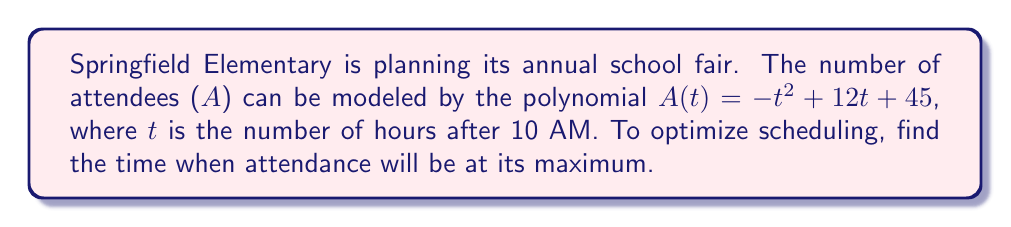Can you answer this question? To find the maximum attendance, we need to find the vertex of the quadratic function $A(t) = -t^2 + 12t + 45$. We can do this by following these steps:

1) The general form of a quadratic function is $f(x) = ax^2 + bx + c$
   In our case, $a = -1$, $b = 12$, and $c = 45$

2) For a quadratic function, the x-coordinate of the vertex is given by $-\frac{b}{2a}$

3) Let's calculate:
   $$t = -\frac{b}{2a} = -\frac{12}{2(-1)} = -\frac{12}{-2} = 6$$

4) This means attendance will be at its maximum 6 hours after 10 AM, which is 4 PM.

5) To verify, we can calculate the y-coordinate of the vertex:
   $$A(6) = -(6)^2 + 12(6) + 45$$
   $$= -36 + 72 + 45 = 81$$

Therefore, the maximum attendance of 81 people will occur at 4 PM.
Answer: 4 PM 